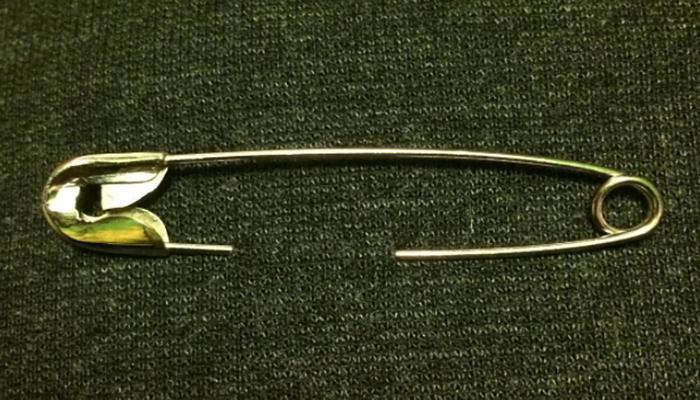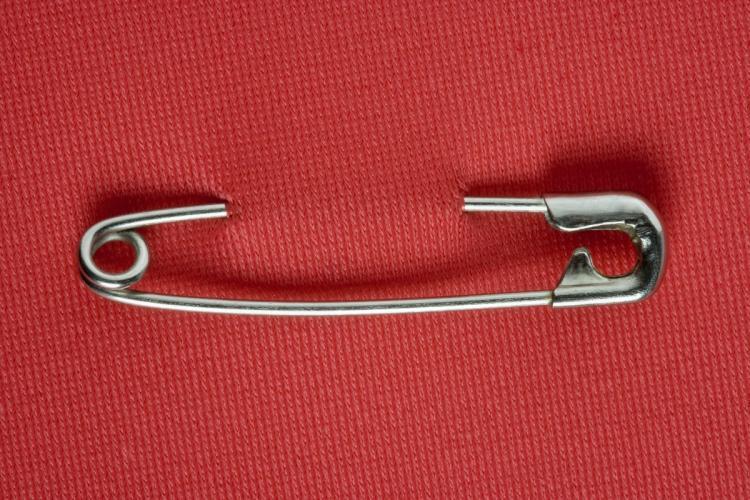The first image is the image on the left, the second image is the image on the right. Analyze the images presented: Is the assertion "An image contains one horizontal silver pin pierced through a solid color material." valid? Answer yes or no. Yes. The first image is the image on the left, the second image is the image on the right. Considering the images on both sides, is "At least one safety pin is pinned through a fabric." valid? Answer yes or no. Yes. 